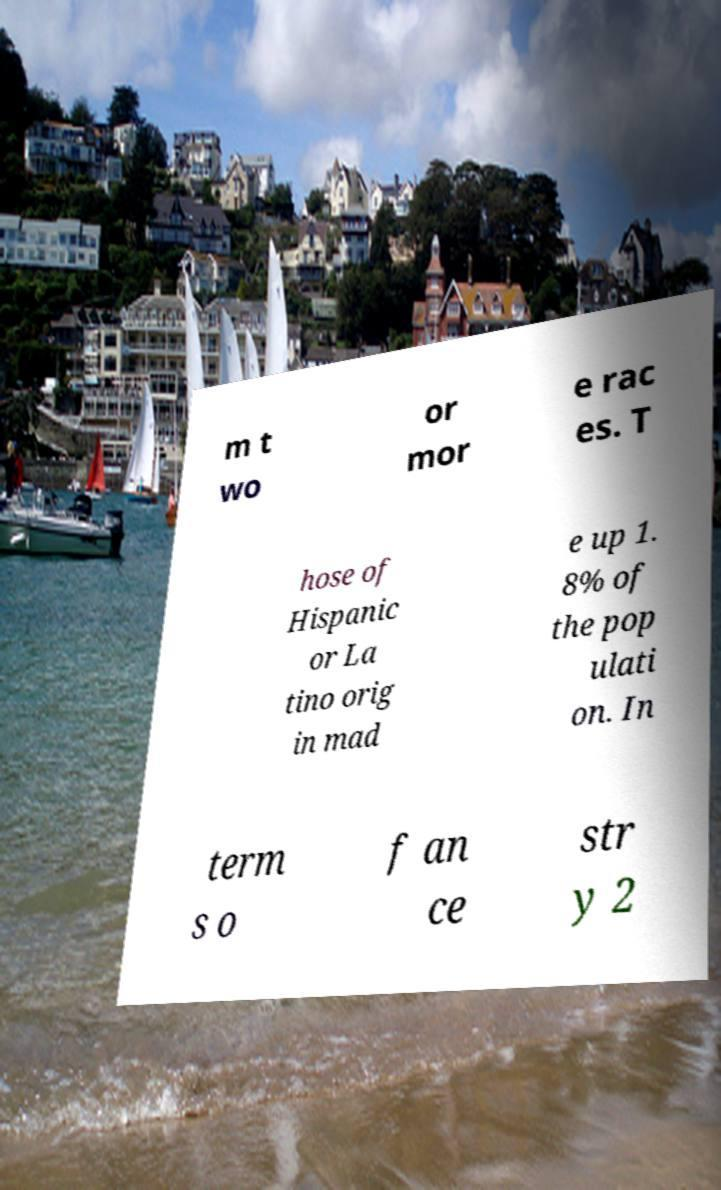Can you read and provide the text displayed in the image?This photo seems to have some interesting text. Can you extract and type it out for me? m t wo or mor e rac es. T hose of Hispanic or La tino orig in mad e up 1. 8% of the pop ulati on. In term s o f an ce str y 2 